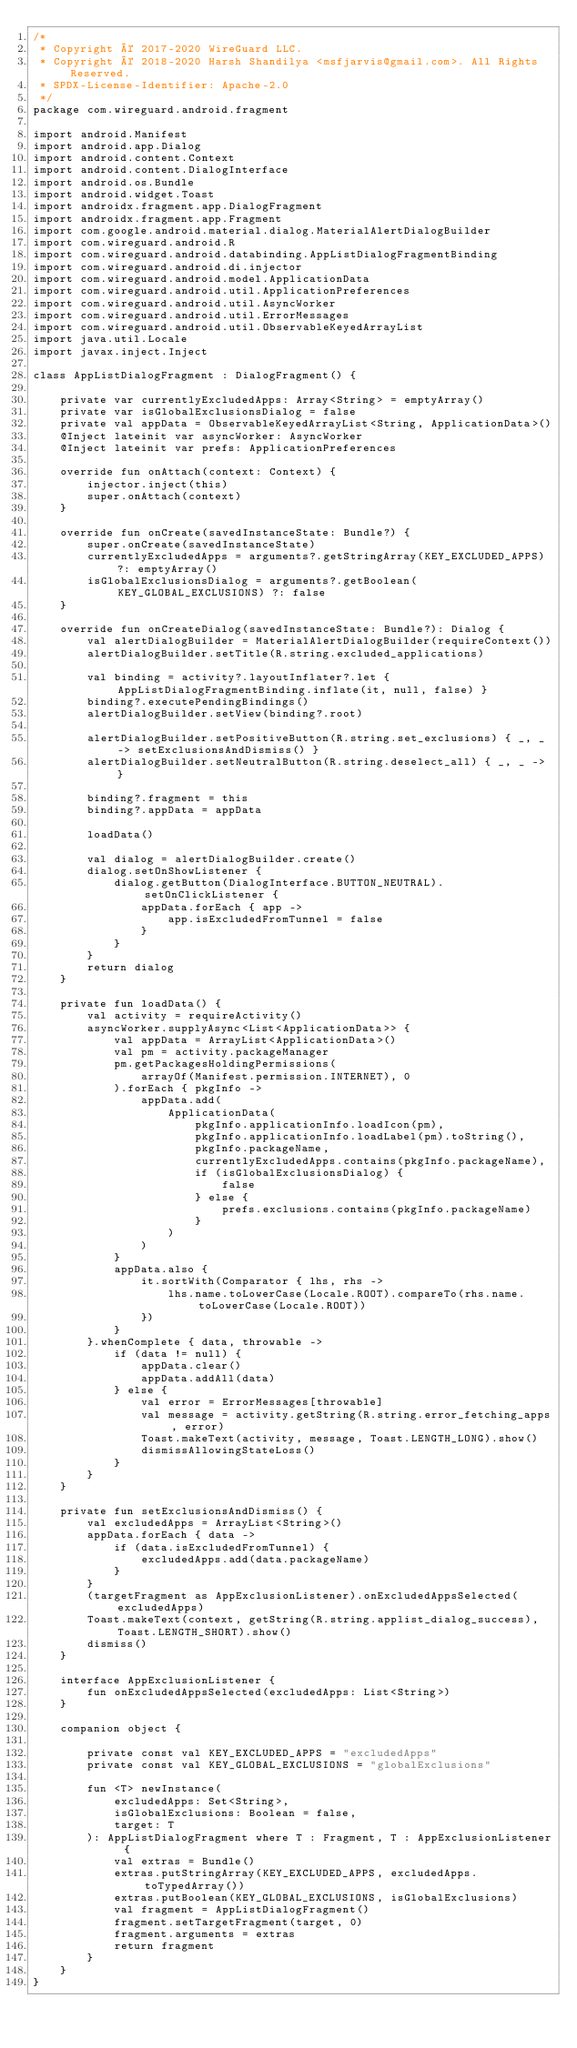Convert code to text. <code><loc_0><loc_0><loc_500><loc_500><_Kotlin_>/*
 * Copyright © 2017-2020 WireGuard LLC.
 * Copyright © 2018-2020 Harsh Shandilya <msfjarvis@gmail.com>. All Rights Reserved.
 * SPDX-License-Identifier: Apache-2.0
 */
package com.wireguard.android.fragment

import android.Manifest
import android.app.Dialog
import android.content.Context
import android.content.DialogInterface
import android.os.Bundle
import android.widget.Toast
import androidx.fragment.app.DialogFragment
import androidx.fragment.app.Fragment
import com.google.android.material.dialog.MaterialAlertDialogBuilder
import com.wireguard.android.R
import com.wireguard.android.databinding.AppListDialogFragmentBinding
import com.wireguard.android.di.injector
import com.wireguard.android.model.ApplicationData
import com.wireguard.android.util.ApplicationPreferences
import com.wireguard.android.util.AsyncWorker
import com.wireguard.android.util.ErrorMessages
import com.wireguard.android.util.ObservableKeyedArrayList
import java.util.Locale
import javax.inject.Inject

class AppListDialogFragment : DialogFragment() {

    private var currentlyExcludedApps: Array<String> = emptyArray()
    private var isGlobalExclusionsDialog = false
    private val appData = ObservableKeyedArrayList<String, ApplicationData>()
    @Inject lateinit var asyncWorker: AsyncWorker
    @Inject lateinit var prefs: ApplicationPreferences

    override fun onAttach(context: Context) {
        injector.inject(this)
        super.onAttach(context)
    }

    override fun onCreate(savedInstanceState: Bundle?) {
        super.onCreate(savedInstanceState)
        currentlyExcludedApps = arguments?.getStringArray(KEY_EXCLUDED_APPS) ?: emptyArray()
        isGlobalExclusionsDialog = arguments?.getBoolean(KEY_GLOBAL_EXCLUSIONS) ?: false
    }

    override fun onCreateDialog(savedInstanceState: Bundle?): Dialog {
        val alertDialogBuilder = MaterialAlertDialogBuilder(requireContext())
        alertDialogBuilder.setTitle(R.string.excluded_applications)

        val binding = activity?.layoutInflater?.let { AppListDialogFragmentBinding.inflate(it, null, false) }
        binding?.executePendingBindings()
        alertDialogBuilder.setView(binding?.root)

        alertDialogBuilder.setPositiveButton(R.string.set_exclusions) { _, _ -> setExclusionsAndDismiss() }
        alertDialogBuilder.setNeutralButton(R.string.deselect_all) { _, _ -> }

        binding?.fragment = this
        binding?.appData = appData

        loadData()

        val dialog = alertDialogBuilder.create()
        dialog.setOnShowListener {
            dialog.getButton(DialogInterface.BUTTON_NEUTRAL).setOnClickListener {
                appData.forEach { app ->
                    app.isExcludedFromTunnel = false
                }
            }
        }
        return dialog
    }

    private fun loadData() {
        val activity = requireActivity()
        asyncWorker.supplyAsync<List<ApplicationData>> {
            val appData = ArrayList<ApplicationData>()
            val pm = activity.packageManager
            pm.getPackagesHoldingPermissions(
                arrayOf(Manifest.permission.INTERNET), 0
            ).forEach { pkgInfo ->
                appData.add(
                    ApplicationData(
                        pkgInfo.applicationInfo.loadIcon(pm),
                        pkgInfo.applicationInfo.loadLabel(pm).toString(),
                        pkgInfo.packageName,
                        currentlyExcludedApps.contains(pkgInfo.packageName),
                        if (isGlobalExclusionsDialog) {
                            false
                        } else {
                            prefs.exclusions.contains(pkgInfo.packageName)
                        }
                    )
                )
            }
            appData.also {
                it.sortWith(Comparator { lhs, rhs ->
                    lhs.name.toLowerCase(Locale.ROOT).compareTo(rhs.name.toLowerCase(Locale.ROOT))
                })
            }
        }.whenComplete { data, throwable ->
            if (data != null) {
                appData.clear()
                appData.addAll(data)
            } else {
                val error = ErrorMessages[throwable]
                val message = activity.getString(R.string.error_fetching_apps, error)
                Toast.makeText(activity, message, Toast.LENGTH_LONG).show()
                dismissAllowingStateLoss()
            }
        }
    }

    private fun setExclusionsAndDismiss() {
        val excludedApps = ArrayList<String>()
        appData.forEach { data ->
            if (data.isExcludedFromTunnel) {
                excludedApps.add(data.packageName)
            }
        }
        (targetFragment as AppExclusionListener).onExcludedAppsSelected(excludedApps)
        Toast.makeText(context, getString(R.string.applist_dialog_success), Toast.LENGTH_SHORT).show()
        dismiss()
    }

    interface AppExclusionListener {
        fun onExcludedAppsSelected(excludedApps: List<String>)
    }

    companion object {

        private const val KEY_EXCLUDED_APPS = "excludedApps"
        private const val KEY_GLOBAL_EXCLUSIONS = "globalExclusions"

        fun <T> newInstance(
            excludedApps: Set<String>,
            isGlobalExclusions: Boolean = false,
            target: T
        ): AppListDialogFragment where T : Fragment, T : AppExclusionListener {
            val extras = Bundle()
            extras.putStringArray(KEY_EXCLUDED_APPS, excludedApps.toTypedArray())
            extras.putBoolean(KEY_GLOBAL_EXCLUSIONS, isGlobalExclusions)
            val fragment = AppListDialogFragment()
            fragment.setTargetFragment(target, 0)
            fragment.arguments = extras
            return fragment
        }
    }
}
</code> 